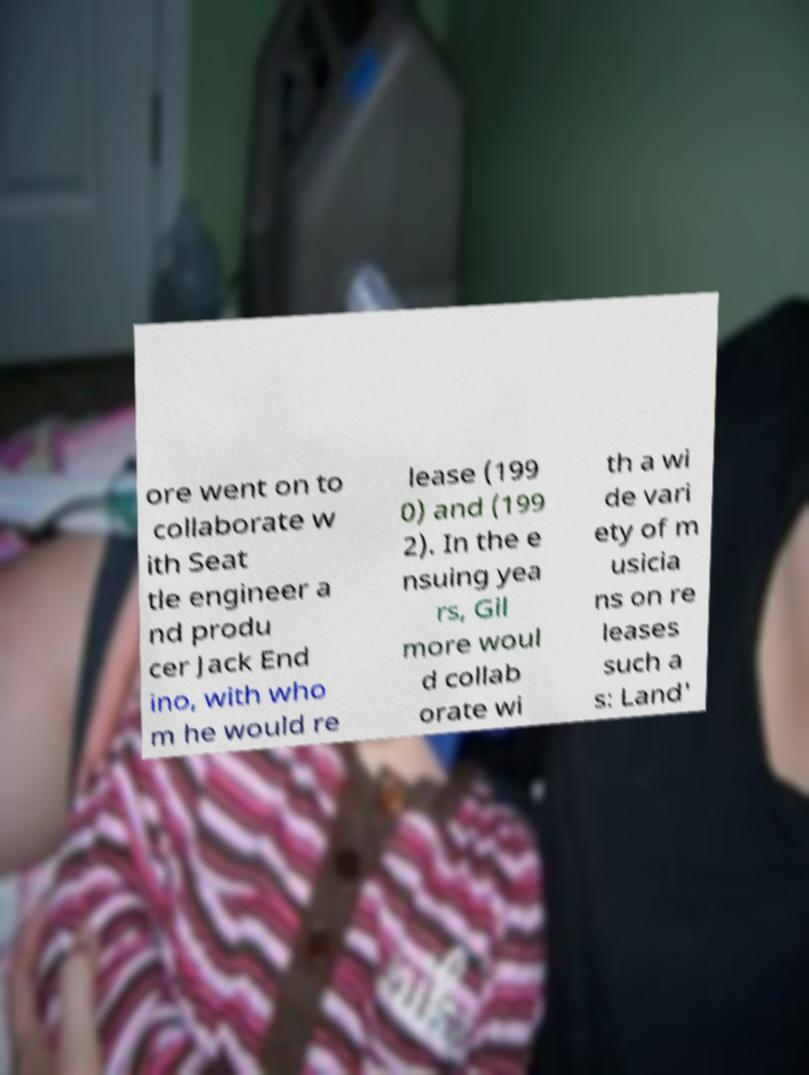Can you read and provide the text displayed in the image?This photo seems to have some interesting text. Can you extract and type it out for me? ore went on to collaborate w ith Seat tle engineer a nd produ cer Jack End ino, with who m he would re lease (199 0) and (199 2). In the e nsuing yea rs, Gil more woul d collab orate wi th a wi de vari ety of m usicia ns on re leases such a s: Land' 